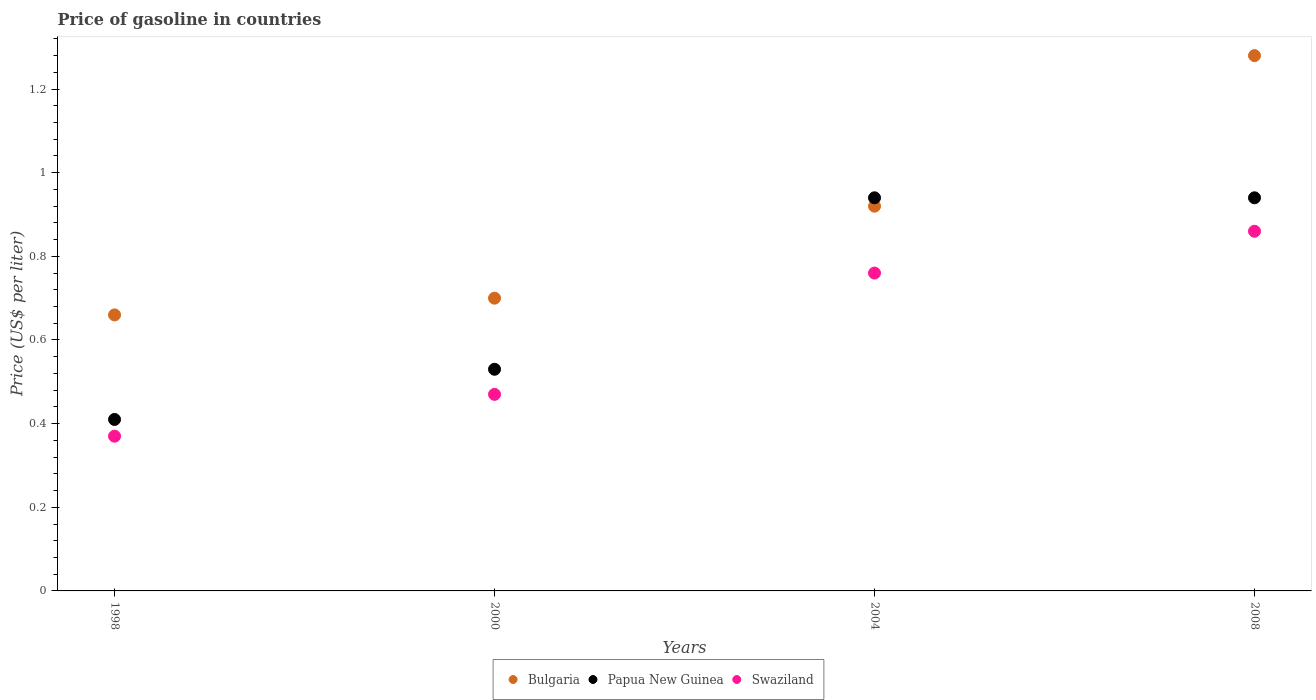Is the number of dotlines equal to the number of legend labels?
Give a very brief answer. Yes. What is the price of gasoline in Papua New Guinea in 1998?
Provide a short and direct response. 0.41. Across all years, what is the maximum price of gasoline in Swaziland?
Provide a succinct answer. 0.86. Across all years, what is the minimum price of gasoline in Swaziland?
Your response must be concise. 0.37. In which year was the price of gasoline in Bulgaria maximum?
Give a very brief answer. 2008. What is the total price of gasoline in Swaziland in the graph?
Give a very brief answer. 2.46. What is the difference between the price of gasoline in Bulgaria in 2000 and that in 2004?
Your answer should be very brief. -0.22. What is the difference between the price of gasoline in Papua New Guinea in 2004 and the price of gasoline in Swaziland in 2000?
Offer a terse response. 0.47. What is the average price of gasoline in Bulgaria per year?
Your answer should be compact. 0.89. In the year 2004, what is the difference between the price of gasoline in Bulgaria and price of gasoline in Swaziland?
Provide a succinct answer. 0.16. In how many years, is the price of gasoline in Papua New Guinea greater than 0.16 US$?
Provide a succinct answer. 4. What is the ratio of the price of gasoline in Bulgaria in 1998 to that in 2008?
Your response must be concise. 0.52. Is the price of gasoline in Swaziland in 2000 less than that in 2008?
Provide a succinct answer. Yes. Is the difference between the price of gasoline in Bulgaria in 1998 and 2004 greater than the difference between the price of gasoline in Swaziland in 1998 and 2004?
Make the answer very short. Yes. What is the difference between the highest and the second highest price of gasoline in Swaziland?
Offer a very short reply. 0.1. What is the difference between the highest and the lowest price of gasoline in Papua New Guinea?
Provide a short and direct response. 0.53. Is the sum of the price of gasoline in Bulgaria in 1998 and 2008 greater than the maximum price of gasoline in Papua New Guinea across all years?
Ensure brevity in your answer.  Yes. Does the price of gasoline in Papua New Guinea monotonically increase over the years?
Keep it short and to the point. No. Is the price of gasoline in Bulgaria strictly greater than the price of gasoline in Papua New Guinea over the years?
Your response must be concise. No. How many years are there in the graph?
Offer a very short reply. 4. What is the difference between two consecutive major ticks on the Y-axis?
Offer a terse response. 0.2. Are the values on the major ticks of Y-axis written in scientific E-notation?
Provide a short and direct response. No. Does the graph contain any zero values?
Provide a succinct answer. No. How many legend labels are there?
Your answer should be very brief. 3. What is the title of the graph?
Make the answer very short. Price of gasoline in countries. What is the label or title of the Y-axis?
Provide a succinct answer. Price (US$ per liter). What is the Price (US$ per liter) in Bulgaria in 1998?
Ensure brevity in your answer.  0.66. What is the Price (US$ per liter) in Papua New Guinea in 1998?
Keep it short and to the point. 0.41. What is the Price (US$ per liter) in Swaziland in 1998?
Offer a very short reply. 0.37. What is the Price (US$ per liter) of Bulgaria in 2000?
Offer a terse response. 0.7. What is the Price (US$ per liter) in Papua New Guinea in 2000?
Ensure brevity in your answer.  0.53. What is the Price (US$ per liter) in Swaziland in 2000?
Ensure brevity in your answer.  0.47. What is the Price (US$ per liter) of Bulgaria in 2004?
Give a very brief answer. 0.92. What is the Price (US$ per liter) in Papua New Guinea in 2004?
Provide a succinct answer. 0.94. What is the Price (US$ per liter) in Swaziland in 2004?
Your answer should be very brief. 0.76. What is the Price (US$ per liter) of Bulgaria in 2008?
Ensure brevity in your answer.  1.28. What is the Price (US$ per liter) in Papua New Guinea in 2008?
Your answer should be compact. 0.94. What is the Price (US$ per liter) in Swaziland in 2008?
Give a very brief answer. 0.86. Across all years, what is the maximum Price (US$ per liter) of Bulgaria?
Offer a very short reply. 1.28. Across all years, what is the maximum Price (US$ per liter) of Papua New Guinea?
Provide a short and direct response. 0.94. Across all years, what is the maximum Price (US$ per liter) of Swaziland?
Your answer should be very brief. 0.86. Across all years, what is the minimum Price (US$ per liter) in Bulgaria?
Provide a short and direct response. 0.66. Across all years, what is the minimum Price (US$ per liter) in Papua New Guinea?
Your response must be concise. 0.41. Across all years, what is the minimum Price (US$ per liter) of Swaziland?
Provide a short and direct response. 0.37. What is the total Price (US$ per liter) in Bulgaria in the graph?
Ensure brevity in your answer.  3.56. What is the total Price (US$ per liter) in Papua New Guinea in the graph?
Give a very brief answer. 2.82. What is the total Price (US$ per liter) in Swaziland in the graph?
Offer a terse response. 2.46. What is the difference between the Price (US$ per liter) in Bulgaria in 1998 and that in 2000?
Provide a short and direct response. -0.04. What is the difference between the Price (US$ per liter) of Papua New Guinea in 1998 and that in 2000?
Keep it short and to the point. -0.12. What is the difference between the Price (US$ per liter) of Swaziland in 1998 and that in 2000?
Offer a very short reply. -0.1. What is the difference between the Price (US$ per liter) of Bulgaria in 1998 and that in 2004?
Provide a succinct answer. -0.26. What is the difference between the Price (US$ per liter) in Papua New Guinea in 1998 and that in 2004?
Your answer should be very brief. -0.53. What is the difference between the Price (US$ per liter) of Swaziland in 1998 and that in 2004?
Offer a terse response. -0.39. What is the difference between the Price (US$ per liter) of Bulgaria in 1998 and that in 2008?
Make the answer very short. -0.62. What is the difference between the Price (US$ per liter) in Papua New Guinea in 1998 and that in 2008?
Your response must be concise. -0.53. What is the difference between the Price (US$ per liter) in Swaziland in 1998 and that in 2008?
Keep it short and to the point. -0.49. What is the difference between the Price (US$ per liter) of Bulgaria in 2000 and that in 2004?
Your answer should be very brief. -0.22. What is the difference between the Price (US$ per liter) of Papua New Guinea in 2000 and that in 2004?
Give a very brief answer. -0.41. What is the difference between the Price (US$ per liter) of Swaziland in 2000 and that in 2004?
Ensure brevity in your answer.  -0.29. What is the difference between the Price (US$ per liter) in Bulgaria in 2000 and that in 2008?
Keep it short and to the point. -0.58. What is the difference between the Price (US$ per liter) of Papua New Guinea in 2000 and that in 2008?
Provide a short and direct response. -0.41. What is the difference between the Price (US$ per liter) in Swaziland in 2000 and that in 2008?
Your response must be concise. -0.39. What is the difference between the Price (US$ per liter) of Bulgaria in 2004 and that in 2008?
Keep it short and to the point. -0.36. What is the difference between the Price (US$ per liter) in Papua New Guinea in 2004 and that in 2008?
Give a very brief answer. 0. What is the difference between the Price (US$ per liter) in Swaziland in 2004 and that in 2008?
Ensure brevity in your answer.  -0.1. What is the difference between the Price (US$ per liter) in Bulgaria in 1998 and the Price (US$ per liter) in Papua New Guinea in 2000?
Keep it short and to the point. 0.13. What is the difference between the Price (US$ per liter) in Bulgaria in 1998 and the Price (US$ per liter) in Swaziland in 2000?
Offer a terse response. 0.19. What is the difference between the Price (US$ per liter) in Papua New Guinea in 1998 and the Price (US$ per liter) in Swaziland in 2000?
Your answer should be very brief. -0.06. What is the difference between the Price (US$ per liter) of Bulgaria in 1998 and the Price (US$ per liter) of Papua New Guinea in 2004?
Your answer should be very brief. -0.28. What is the difference between the Price (US$ per liter) of Bulgaria in 1998 and the Price (US$ per liter) of Swaziland in 2004?
Your response must be concise. -0.1. What is the difference between the Price (US$ per liter) of Papua New Guinea in 1998 and the Price (US$ per liter) of Swaziland in 2004?
Provide a succinct answer. -0.35. What is the difference between the Price (US$ per liter) of Bulgaria in 1998 and the Price (US$ per liter) of Papua New Guinea in 2008?
Give a very brief answer. -0.28. What is the difference between the Price (US$ per liter) in Papua New Guinea in 1998 and the Price (US$ per liter) in Swaziland in 2008?
Your answer should be compact. -0.45. What is the difference between the Price (US$ per liter) in Bulgaria in 2000 and the Price (US$ per liter) in Papua New Guinea in 2004?
Give a very brief answer. -0.24. What is the difference between the Price (US$ per liter) in Bulgaria in 2000 and the Price (US$ per liter) in Swaziland in 2004?
Your response must be concise. -0.06. What is the difference between the Price (US$ per liter) of Papua New Guinea in 2000 and the Price (US$ per liter) of Swaziland in 2004?
Provide a succinct answer. -0.23. What is the difference between the Price (US$ per liter) in Bulgaria in 2000 and the Price (US$ per liter) in Papua New Guinea in 2008?
Make the answer very short. -0.24. What is the difference between the Price (US$ per liter) of Bulgaria in 2000 and the Price (US$ per liter) of Swaziland in 2008?
Make the answer very short. -0.16. What is the difference between the Price (US$ per liter) in Papua New Guinea in 2000 and the Price (US$ per liter) in Swaziland in 2008?
Offer a terse response. -0.33. What is the difference between the Price (US$ per liter) of Bulgaria in 2004 and the Price (US$ per liter) of Papua New Guinea in 2008?
Your answer should be very brief. -0.02. What is the difference between the Price (US$ per liter) of Papua New Guinea in 2004 and the Price (US$ per liter) of Swaziland in 2008?
Give a very brief answer. 0.08. What is the average Price (US$ per liter) of Bulgaria per year?
Offer a terse response. 0.89. What is the average Price (US$ per liter) of Papua New Guinea per year?
Your answer should be very brief. 0.7. What is the average Price (US$ per liter) of Swaziland per year?
Offer a terse response. 0.61. In the year 1998, what is the difference between the Price (US$ per liter) of Bulgaria and Price (US$ per liter) of Papua New Guinea?
Make the answer very short. 0.25. In the year 1998, what is the difference between the Price (US$ per liter) in Bulgaria and Price (US$ per liter) in Swaziland?
Provide a succinct answer. 0.29. In the year 1998, what is the difference between the Price (US$ per liter) of Papua New Guinea and Price (US$ per liter) of Swaziland?
Offer a very short reply. 0.04. In the year 2000, what is the difference between the Price (US$ per liter) in Bulgaria and Price (US$ per liter) in Papua New Guinea?
Give a very brief answer. 0.17. In the year 2000, what is the difference between the Price (US$ per liter) of Bulgaria and Price (US$ per liter) of Swaziland?
Make the answer very short. 0.23. In the year 2000, what is the difference between the Price (US$ per liter) in Papua New Guinea and Price (US$ per liter) in Swaziland?
Your response must be concise. 0.06. In the year 2004, what is the difference between the Price (US$ per liter) of Bulgaria and Price (US$ per liter) of Papua New Guinea?
Provide a succinct answer. -0.02. In the year 2004, what is the difference between the Price (US$ per liter) in Bulgaria and Price (US$ per liter) in Swaziland?
Your answer should be very brief. 0.16. In the year 2004, what is the difference between the Price (US$ per liter) of Papua New Guinea and Price (US$ per liter) of Swaziland?
Your answer should be very brief. 0.18. In the year 2008, what is the difference between the Price (US$ per liter) in Bulgaria and Price (US$ per liter) in Papua New Guinea?
Keep it short and to the point. 0.34. In the year 2008, what is the difference between the Price (US$ per liter) in Bulgaria and Price (US$ per liter) in Swaziland?
Give a very brief answer. 0.42. What is the ratio of the Price (US$ per liter) in Bulgaria in 1998 to that in 2000?
Offer a very short reply. 0.94. What is the ratio of the Price (US$ per liter) in Papua New Guinea in 1998 to that in 2000?
Your response must be concise. 0.77. What is the ratio of the Price (US$ per liter) in Swaziland in 1998 to that in 2000?
Your response must be concise. 0.79. What is the ratio of the Price (US$ per liter) of Bulgaria in 1998 to that in 2004?
Offer a terse response. 0.72. What is the ratio of the Price (US$ per liter) in Papua New Guinea in 1998 to that in 2004?
Offer a terse response. 0.44. What is the ratio of the Price (US$ per liter) of Swaziland in 1998 to that in 2004?
Your answer should be very brief. 0.49. What is the ratio of the Price (US$ per liter) of Bulgaria in 1998 to that in 2008?
Offer a terse response. 0.52. What is the ratio of the Price (US$ per liter) of Papua New Guinea in 1998 to that in 2008?
Your answer should be compact. 0.44. What is the ratio of the Price (US$ per liter) of Swaziland in 1998 to that in 2008?
Your response must be concise. 0.43. What is the ratio of the Price (US$ per liter) in Bulgaria in 2000 to that in 2004?
Provide a short and direct response. 0.76. What is the ratio of the Price (US$ per liter) in Papua New Guinea in 2000 to that in 2004?
Give a very brief answer. 0.56. What is the ratio of the Price (US$ per liter) in Swaziland in 2000 to that in 2004?
Your answer should be very brief. 0.62. What is the ratio of the Price (US$ per liter) in Bulgaria in 2000 to that in 2008?
Provide a succinct answer. 0.55. What is the ratio of the Price (US$ per liter) of Papua New Guinea in 2000 to that in 2008?
Provide a succinct answer. 0.56. What is the ratio of the Price (US$ per liter) in Swaziland in 2000 to that in 2008?
Provide a succinct answer. 0.55. What is the ratio of the Price (US$ per liter) of Bulgaria in 2004 to that in 2008?
Keep it short and to the point. 0.72. What is the ratio of the Price (US$ per liter) in Swaziland in 2004 to that in 2008?
Offer a very short reply. 0.88. What is the difference between the highest and the second highest Price (US$ per liter) in Bulgaria?
Ensure brevity in your answer.  0.36. What is the difference between the highest and the second highest Price (US$ per liter) of Papua New Guinea?
Give a very brief answer. 0. What is the difference between the highest and the lowest Price (US$ per liter) of Bulgaria?
Give a very brief answer. 0.62. What is the difference between the highest and the lowest Price (US$ per liter) in Papua New Guinea?
Provide a short and direct response. 0.53. What is the difference between the highest and the lowest Price (US$ per liter) in Swaziland?
Give a very brief answer. 0.49. 